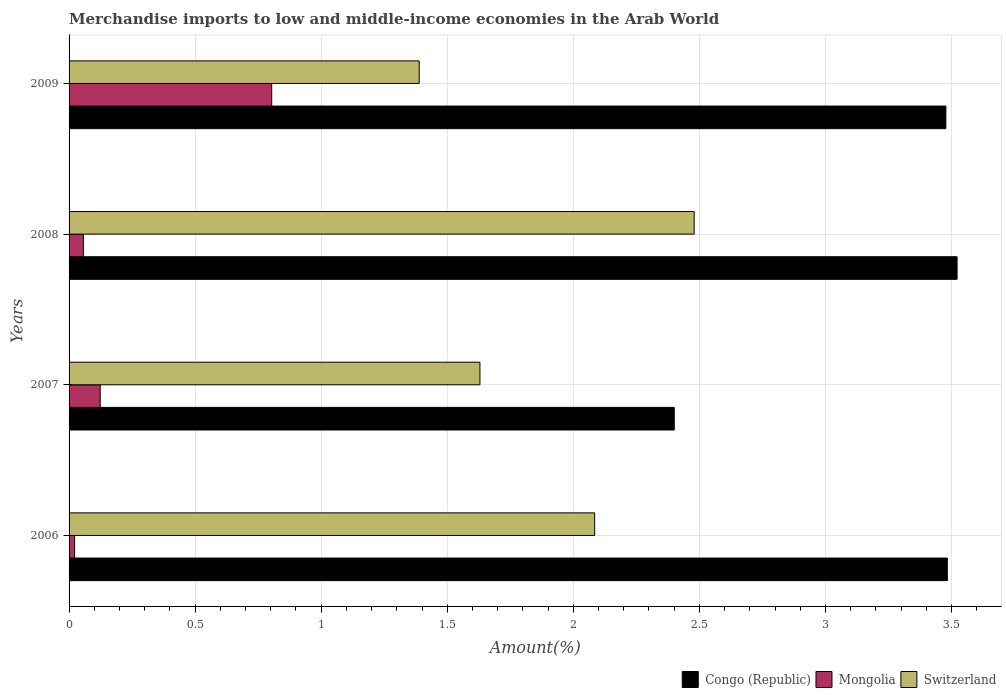How many bars are there on the 1st tick from the top?
Your answer should be very brief. 3. What is the label of the 1st group of bars from the top?
Give a very brief answer. 2009. What is the percentage of amount earned from merchandise imports in Congo (Republic) in 2007?
Your response must be concise. 2.4. Across all years, what is the maximum percentage of amount earned from merchandise imports in Congo (Republic)?
Make the answer very short. 3.52. Across all years, what is the minimum percentage of amount earned from merchandise imports in Congo (Republic)?
Your response must be concise. 2.4. What is the total percentage of amount earned from merchandise imports in Mongolia in the graph?
Offer a very short reply. 1.01. What is the difference between the percentage of amount earned from merchandise imports in Congo (Republic) in 2006 and that in 2007?
Your answer should be very brief. 1.08. What is the difference between the percentage of amount earned from merchandise imports in Switzerland in 2009 and the percentage of amount earned from merchandise imports in Congo (Republic) in 2007?
Ensure brevity in your answer.  -1.01. What is the average percentage of amount earned from merchandise imports in Congo (Republic) per year?
Keep it short and to the point. 3.22. In the year 2008, what is the difference between the percentage of amount earned from merchandise imports in Congo (Republic) and percentage of amount earned from merchandise imports in Switzerland?
Your answer should be very brief. 1.04. In how many years, is the percentage of amount earned from merchandise imports in Congo (Republic) greater than 1.1 %?
Ensure brevity in your answer.  4. What is the ratio of the percentage of amount earned from merchandise imports in Switzerland in 2006 to that in 2008?
Keep it short and to the point. 0.84. Is the difference between the percentage of amount earned from merchandise imports in Congo (Republic) in 2007 and 2009 greater than the difference between the percentage of amount earned from merchandise imports in Switzerland in 2007 and 2009?
Your answer should be compact. No. What is the difference between the highest and the second highest percentage of amount earned from merchandise imports in Congo (Republic)?
Give a very brief answer. 0.04. What is the difference between the highest and the lowest percentage of amount earned from merchandise imports in Switzerland?
Your answer should be very brief. 1.09. In how many years, is the percentage of amount earned from merchandise imports in Switzerland greater than the average percentage of amount earned from merchandise imports in Switzerland taken over all years?
Make the answer very short. 2. What does the 2nd bar from the top in 2009 represents?
Provide a short and direct response. Mongolia. What does the 1st bar from the bottom in 2008 represents?
Keep it short and to the point. Congo (Republic). Is it the case that in every year, the sum of the percentage of amount earned from merchandise imports in Congo (Republic) and percentage of amount earned from merchandise imports in Switzerland is greater than the percentage of amount earned from merchandise imports in Mongolia?
Offer a terse response. Yes. What is the difference between two consecutive major ticks on the X-axis?
Your answer should be compact. 0.5. Are the values on the major ticks of X-axis written in scientific E-notation?
Your answer should be very brief. No. Does the graph contain grids?
Your answer should be very brief. Yes. Where does the legend appear in the graph?
Offer a terse response. Bottom right. How many legend labels are there?
Ensure brevity in your answer.  3. What is the title of the graph?
Your answer should be very brief. Merchandise imports to low and middle-income economies in the Arab World. What is the label or title of the X-axis?
Ensure brevity in your answer.  Amount(%). What is the Amount(%) in Congo (Republic) in 2006?
Provide a succinct answer. 3.48. What is the Amount(%) in Mongolia in 2006?
Offer a terse response. 0.02. What is the Amount(%) in Switzerland in 2006?
Keep it short and to the point. 2.08. What is the Amount(%) in Congo (Republic) in 2007?
Your answer should be very brief. 2.4. What is the Amount(%) of Mongolia in 2007?
Ensure brevity in your answer.  0.12. What is the Amount(%) of Switzerland in 2007?
Give a very brief answer. 1.63. What is the Amount(%) of Congo (Republic) in 2008?
Offer a terse response. 3.52. What is the Amount(%) of Mongolia in 2008?
Offer a terse response. 0.06. What is the Amount(%) in Switzerland in 2008?
Provide a succinct answer. 2.48. What is the Amount(%) of Congo (Republic) in 2009?
Make the answer very short. 3.48. What is the Amount(%) of Mongolia in 2009?
Your answer should be very brief. 0.8. What is the Amount(%) in Switzerland in 2009?
Make the answer very short. 1.39. Across all years, what is the maximum Amount(%) in Congo (Republic)?
Offer a very short reply. 3.52. Across all years, what is the maximum Amount(%) in Mongolia?
Provide a succinct answer. 0.8. Across all years, what is the maximum Amount(%) of Switzerland?
Offer a very short reply. 2.48. Across all years, what is the minimum Amount(%) in Congo (Republic)?
Your answer should be very brief. 2.4. Across all years, what is the minimum Amount(%) of Mongolia?
Your answer should be compact. 0.02. Across all years, what is the minimum Amount(%) of Switzerland?
Give a very brief answer. 1.39. What is the total Amount(%) in Congo (Republic) in the graph?
Your answer should be compact. 12.88. What is the total Amount(%) in Mongolia in the graph?
Make the answer very short. 1.01. What is the total Amount(%) of Switzerland in the graph?
Make the answer very short. 7.58. What is the difference between the Amount(%) in Congo (Republic) in 2006 and that in 2007?
Offer a very short reply. 1.08. What is the difference between the Amount(%) of Mongolia in 2006 and that in 2007?
Make the answer very short. -0.1. What is the difference between the Amount(%) in Switzerland in 2006 and that in 2007?
Offer a very short reply. 0.46. What is the difference between the Amount(%) in Congo (Republic) in 2006 and that in 2008?
Your answer should be very brief. -0.04. What is the difference between the Amount(%) in Mongolia in 2006 and that in 2008?
Ensure brevity in your answer.  -0.03. What is the difference between the Amount(%) in Switzerland in 2006 and that in 2008?
Your answer should be very brief. -0.39. What is the difference between the Amount(%) in Congo (Republic) in 2006 and that in 2009?
Provide a short and direct response. 0.01. What is the difference between the Amount(%) in Mongolia in 2006 and that in 2009?
Keep it short and to the point. -0.78. What is the difference between the Amount(%) in Switzerland in 2006 and that in 2009?
Provide a short and direct response. 0.7. What is the difference between the Amount(%) of Congo (Republic) in 2007 and that in 2008?
Ensure brevity in your answer.  -1.12. What is the difference between the Amount(%) in Mongolia in 2007 and that in 2008?
Your answer should be compact. 0.07. What is the difference between the Amount(%) in Switzerland in 2007 and that in 2008?
Make the answer very short. -0.85. What is the difference between the Amount(%) of Congo (Republic) in 2007 and that in 2009?
Provide a short and direct response. -1.08. What is the difference between the Amount(%) of Mongolia in 2007 and that in 2009?
Provide a short and direct response. -0.68. What is the difference between the Amount(%) of Switzerland in 2007 and that in 2009?
Your answer should be compact. 0.24. What is the difference between the Amount(%) of Congo (Republic) in 2008 and that in 2009?
Your answer should be very brief. 0.04. What is the difference between the Amount(%) of Mongolia in 2008 and that in 2009?
Make the answer very short. -0.75. What is the difference between the Amount(%) in Switzerland in 2008 and that in 2009?
Provide a short and direct response. 1.09. What is the difference between the Amount(%) of Congo (Republic) in 2006 and the Amount(%) of Mongolia in 2007?
Ensure brevity in your answer.  3.36. What is the difference between the Amount(%) of Congo (Republic) in 2006 and the Amount(%) of Switzerland in 2007?
Offer a very short reply. 1.85. What is the difference between the Amount(%) in Mongolia in 2006 and the Amount(%) in Switzerland in 2007?
Provide a short and direct response. -1.61. What is the difference between the Amount(%) of Congo (Republic) in 2006 and the Amount(%) of Mongolia in 2008?
Your response must be concise. 3.43. What is the difference between the Amount(%) of Congo (Republic) in 2006 and the Amount(%) of Switzerland in 2008?
Ensure brevity in your answer.  1. What is the difference between the Amount(%) in Mongolia in 2006 and the Amount(%) in Switzerland in 2008?
Offer a very short reply. -2.46. What is the difference between the Amount(%) of Congo (Republic) in 2006 and the Amount(%) of Mongolia in 2009?
Make the answer very short. 2.68. What is the difference between the Amount(%) of Congo (Republic) in 2006 and the Amount(%) of Switzerland in 2009?
Offer a terse response. 2.09. What is the difference between the Amount(%) of Mongolia in 2006 and the Amount(%) of Switzerland in 2009?
Your response must be concise. -1.37. What is the difference between the Amount(%) of Congo (Republic) in 2007 and the Amount(%) of Mongolia in 2008?
Your answer should be very brief. 2.34. What is the difference between the Amount(%) in Congo (Republic) in 2007 and the Amount(%) in Switzerland in 2008?
Offer a terse response. -0.08. What is the difference between the Amount(%) in Mongolia in 2007 and the Amount(%) in Switzerland in 2008?
Provide a succinct answer. -2.36. What is the difference between the Amount(%) in Congo (Republic) in 2007 and the Amount(%) in Mongolia in 2009?
Make the answer very short. 1.6. What is the difference between the Amount(%) of Congo (Republic) in 2007 and the Amount(%) of Switzerland in 2009?
Offer a very short reply. 1.01. What is the difference between the Amount(%) in Mongolia in 2007 and the Amount(%) in Switzerland in 2009?
Offer a terse response. -1.27. What is the difference between the Amount(%) in Congo (Republic) in 2008 and the Amount(%) in Mongolia in 2009?
Provide a succinct answer. 2.72. What is the difference between the Amount(%) in Congo (Republic) in 2008 and the Amount(%) in Switzerland in 2009?
Provide a short and direct response. 2.13. What is the difference between the Amount(%) in Mongolia in 2008 and the Amount(%) in Switzerland in 2009?
Provide a succinct answer. -1.33. What is the average Amount(%) of Congo (Republic) per year?
Provide a short and direct response. 3.22. What is the average Amount(%) of Mongolia per year?
Offer a very short reply. 0.25. What is the average Amount(%) in Switzerland per year?
Ensure brevity in your answer.  1.9. In the year 2006, what is the difference between the Amount(%) of Congo (Republic) and Amount(%) of Mongolia?
Give a very brief answer. 3.46. In the year 2006, what is the difference between the Amount(%) of Congo (Republic) and Amount(%) of Switzerland?
Ensure brevity in your answer.  1.4. In the year 2006, what is the difference between the Amount(%) of Mongolia and Amount(%) of Switzerland?
Provide a succinct answer. -2.06. In the year 2007, what is the difference between the Amount(%) in Congo (Republic) and Amount(%) in Mongolia?
Give a very brief answer. 2.28. In the year 2007, what is the difference between the Amount(%) in Congo (Republic) and Amount(%) in Switzerland?
Make the answer very short. 0.77. In the year 2007, what is the difference between the Amount(%) in Mongolia and Amount(%) in Switzerland?
Offer a terse response. -1.51. In the year 2008, what is the difference between the Amount(%) of Congo (Republic) and Amount(%) of Mongolia?
Your response must be concise. 3.47. In the year 2008, what is the difference between the Amount(%) in Congo (Republic) and Amount(%) in Switzerland?
Offer a terse response. 1.04. In the year 2008, what is the difference between the Amount(%) in Mongolia and Amount(%) in Switzerland?
Make the answer very short. -2.42. In the year 2009, what is the difference between the Amount(%) of Congo (Republic) and Amount(%) of Mongolia?
Your answer should be very brief. 2.67. In the year 2009, what is the difference between the Amount(%) in Congo (Republic) and Amount(%) in Switzerland?
Provide a succinct answer. 2.09. In the year 2009, what is the difference between the Amount(%) of Mongolia and Amount(%) of Switzerland?
Provide a succinct answer. -0.58. What is the ratio of the Amount(%) of Congo (Republic) in 2006 to that in 2007?
Offer a terse response. 1.45. What is the ratio of the Amount(%) of Mongolia in 2006 to that in 2007?
Provide a succinct answer. 0.18. What is the ratio of the Amount(%) in Switzerland in 2006 to that in 2007?
Your answer should be compact. 1.28. What is the ratio of the Amount(%) in Congo (Republic) in 2006 to that in 2008?
Keep it short and to the point. 0.99. What is the ratio of the Amount(%) of Mongolia in 2006 to that in 2008?
Offer a terse response. 0.39. What is the ratio of the Amount(%) in Switzerland in 2006 to that in 2008?
Offer a very short reply. 0.84. What is the ratio of the Amount(%) of Congo (Republic) in 2006 to that in 2009?
Offer a terse response. 1. What is the ratio of the Amount(%) of Mongolia in 2006 to that in 2009?
Offer a terse response. 0.03. What is the ratio of the Amount(%) of Switzerland in 2006 to that in 2009?
Provide a short and direct response. 1.5. What is the ratio of the Amount(%) in Congo (Republic) in 2007 to that in 2008?
Provide a short and direct response. 0.68. What is the ratio of the Amount(%) of Mongolia in 2007 to that in 2008?
Provide a short and direct response. 2.17. What is the ratio of the Amount(%) in Switzerland in 2007 to that in 2008?
Your response must be concise. 0.66. What is the ratio of the Amount(%) of Congo (Republic) in 2007 to that in 2009?
Ensure brevity in your answer.  0.69. What is the ratio of the Amount(%) of Mongolia in 2007 to that in 2009?
Make the answer very short. 0.15. What is the ratio of the Amount(%) of Switzerland in 2007 to that in 2009?
Your answer should be very brief. 1.17. What is the ratio of the Amount(%) in Congo (Republic) in 2008 to that in 2009?
Your answer should be very brief. 1.01. What is the ratio of the Amount(%) of Mongolia in 2008 to that in 2009?
Offer a terse response. 0.07. What is the ratio of the Amount(%) of Switzerland in 2008 to that in 2009?
Provide a short and direct response. 1.79. What is the difference between the highest and the second highest Amount(%) in Congo (Republic)?
Give a very brief answer. 0.04. What is the difference between the highest and the second highest Amount(%) in Mongolia?
Offer a terse response. 0.68. What is the difference between the highest and the second highest Amount(%) in Switzerland?
Your response must be concise. 0.39. What is the difference between the highest and the lowest Amount(%) in Congo (Republic)?
Make the answer very short. 1.12. What is the difference between the highest and the lowest Amount(%) in Mongolia?
Give a very brief answer. 0.78. What is the difference between the highest and the lowest Amount(%) in Switzerland?
Provide a short and direct response. 1.09. 